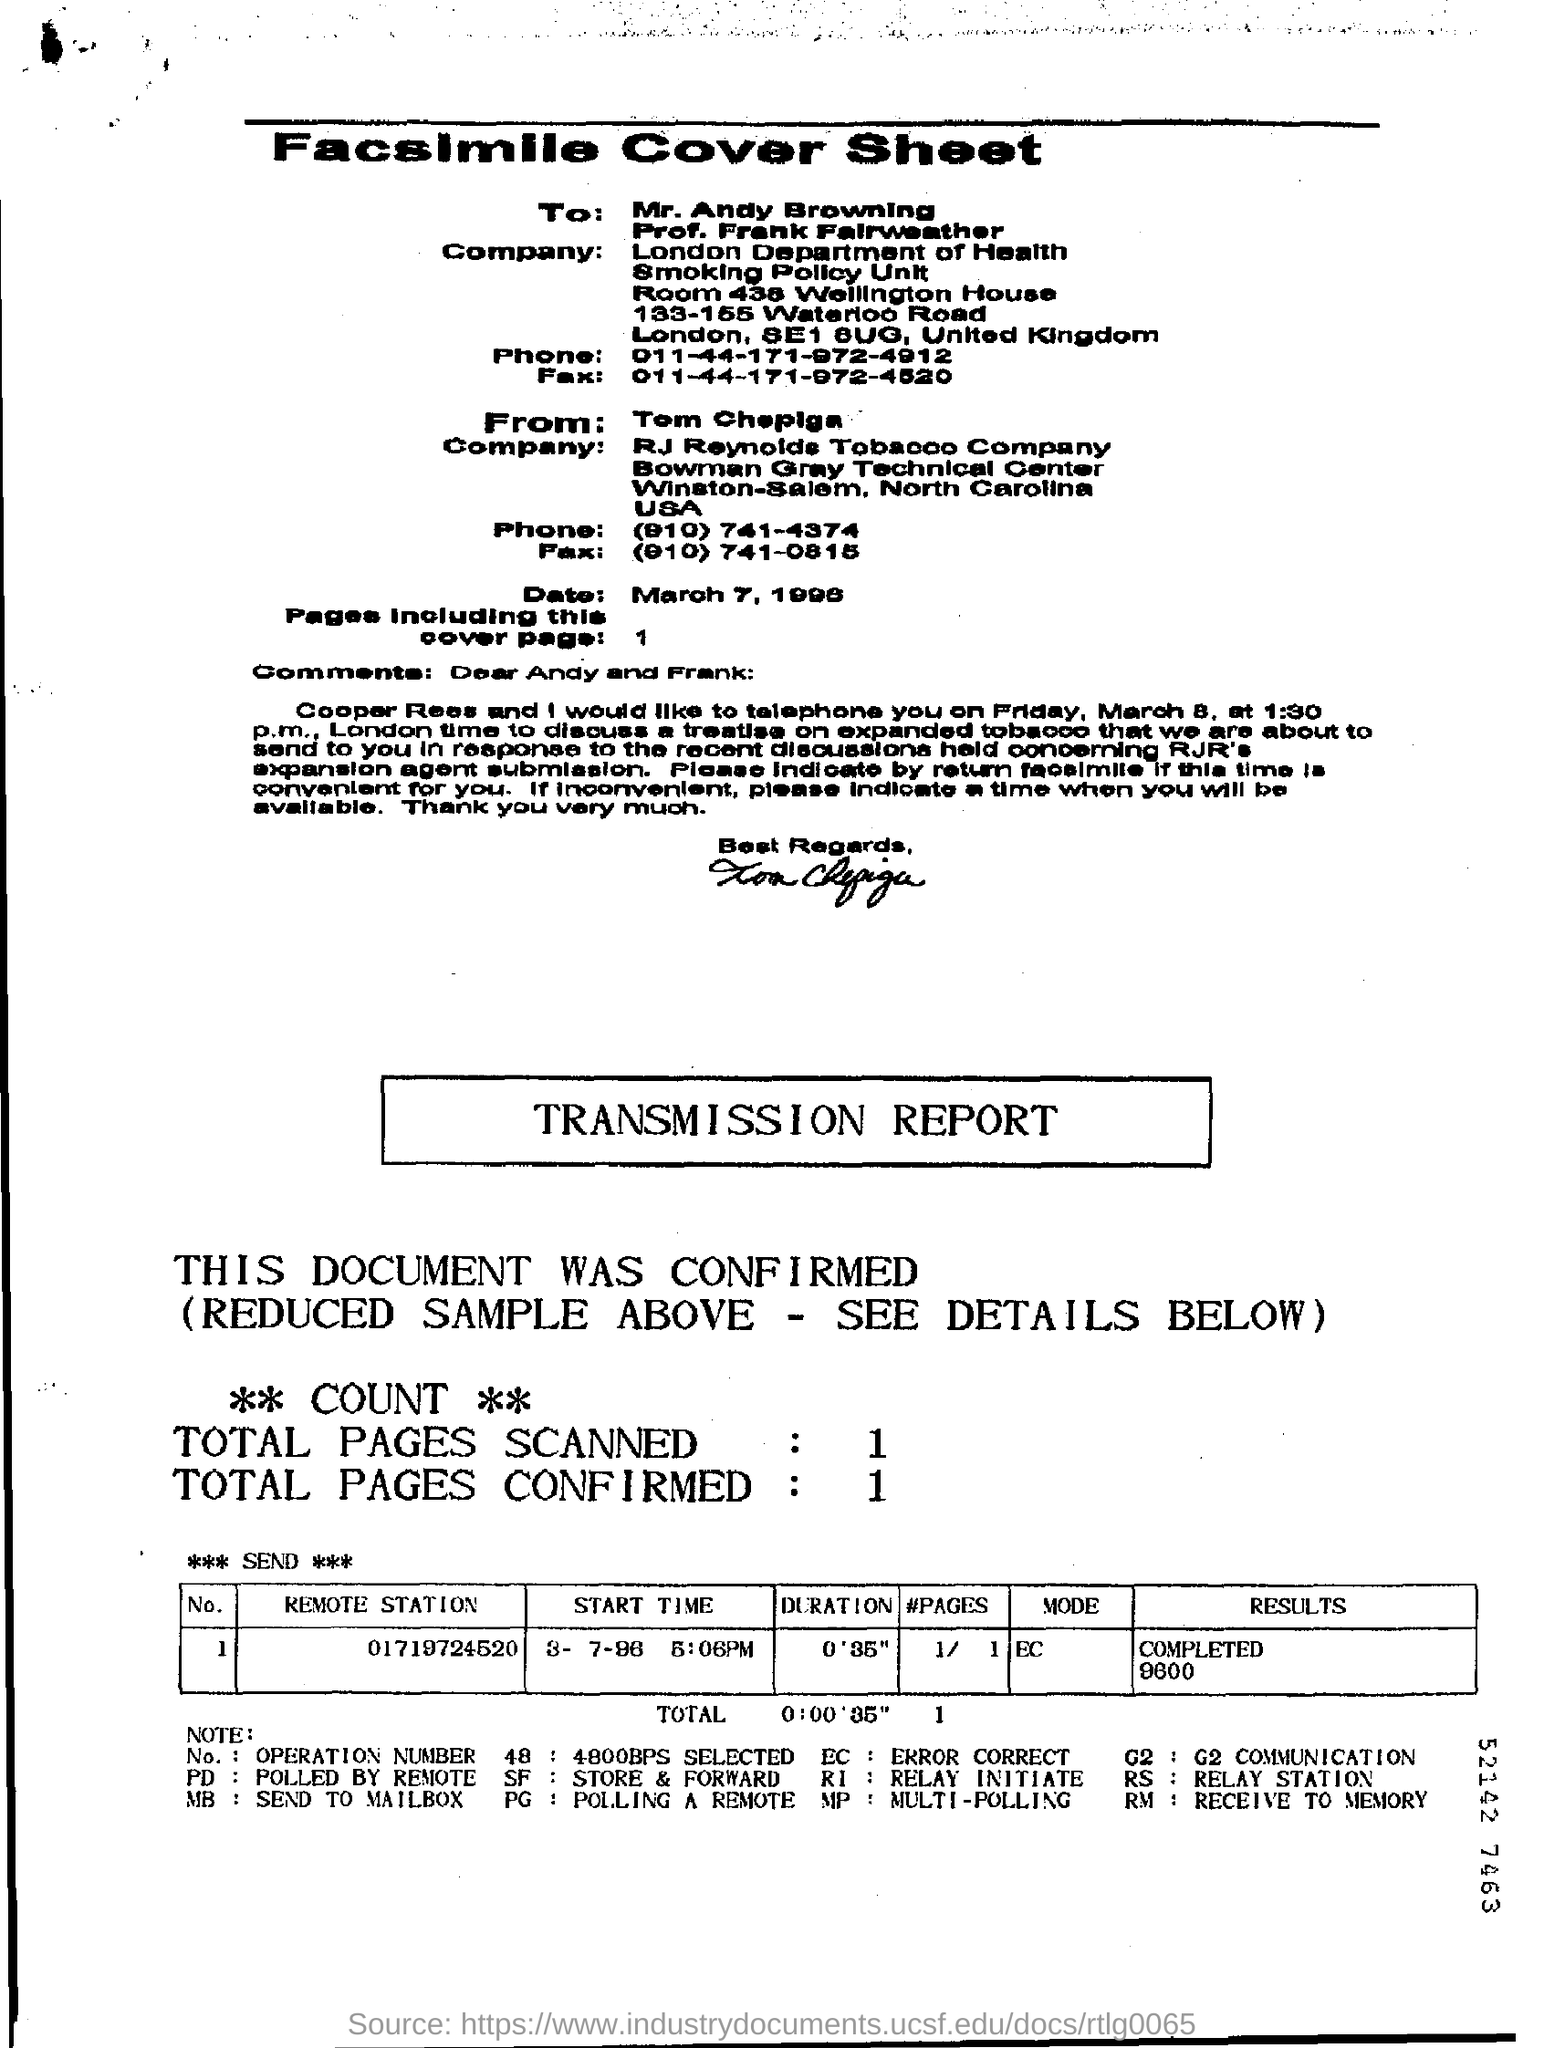What is "RM?
Your answer should be very brief. Receive to memory. 